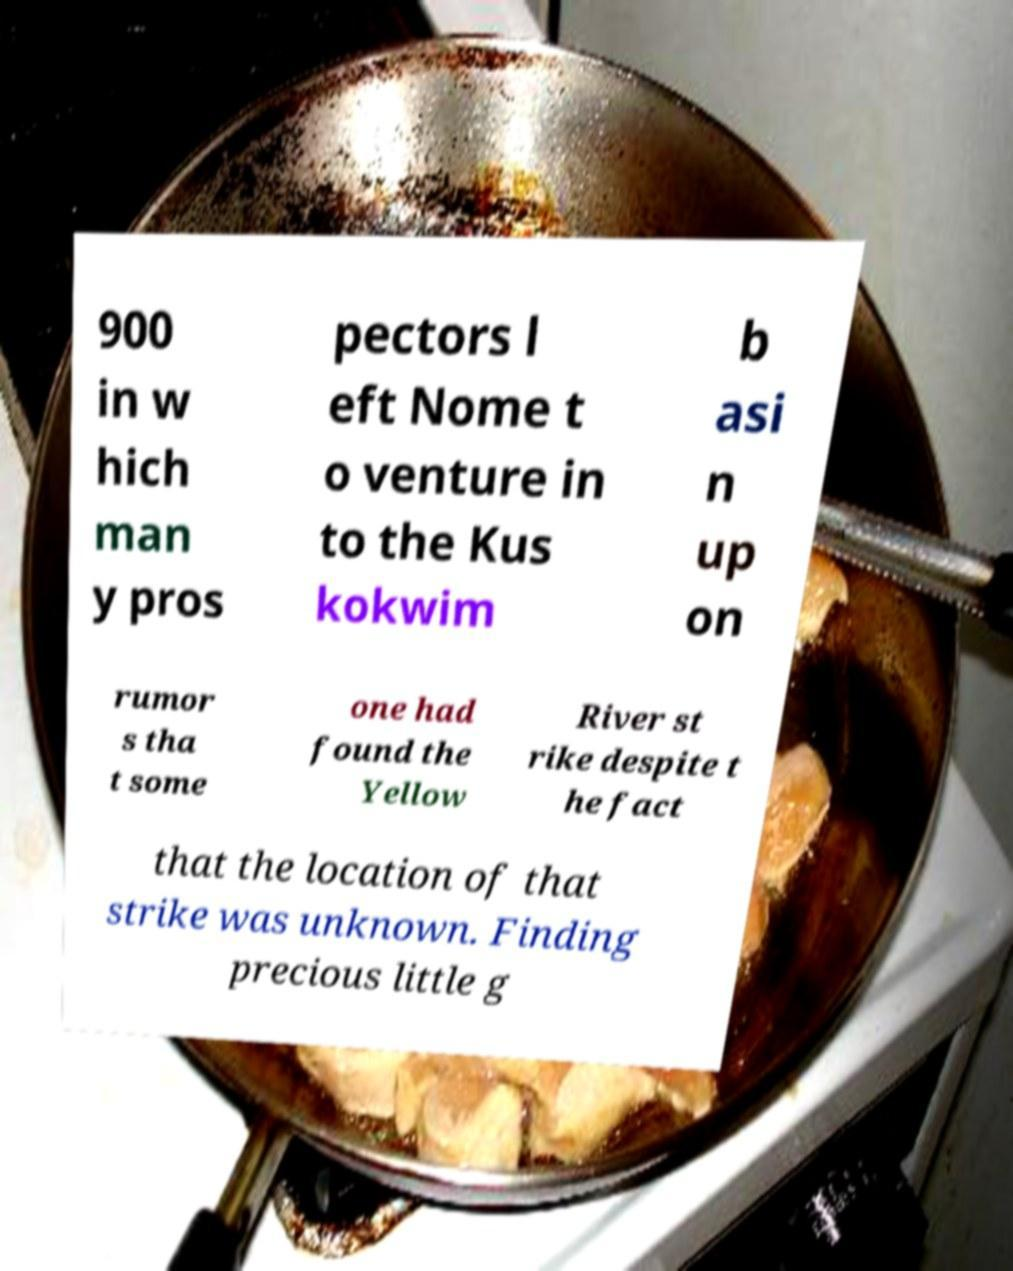I need the written content from this picture converted into text. Can you do that? 900 in w hich man y pros pectors l eft Nome t o venture in to the Kus kokwim b asi n up on rumor s tha t some one had found the Yellow River st rike despite t he fact that the location of that strike was unknown. Finding precious little g 